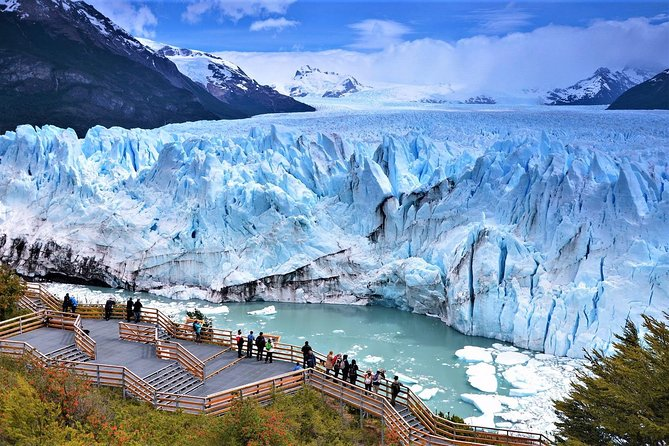How does this glacier compare in size to others around the world? Perito Moreno Glacier is one of the largest in Patagonia, covering about 250 square kilometers. Though impressive, it is smaller than some of the world's largest like the Lambert Glacier in Antarctica, which extends over 8,000 square kilometers. However, Perito Moreno is unique as it is one of the few glaciers that is still advancing, whereas many others worldwide are retreating due to climate change. 